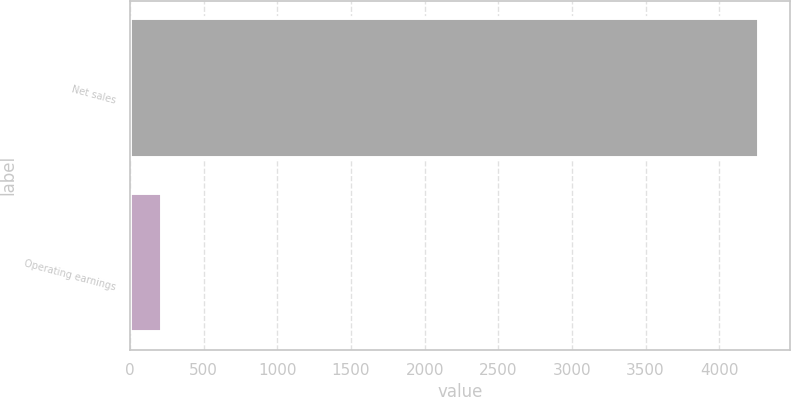<chart> <loc_0><loc_0><loc_500><loc_500><bar_chart><fcel>Net sales<fcel>Operating earnings<nl><fcel>4271<fcel>216<nl></chart> 